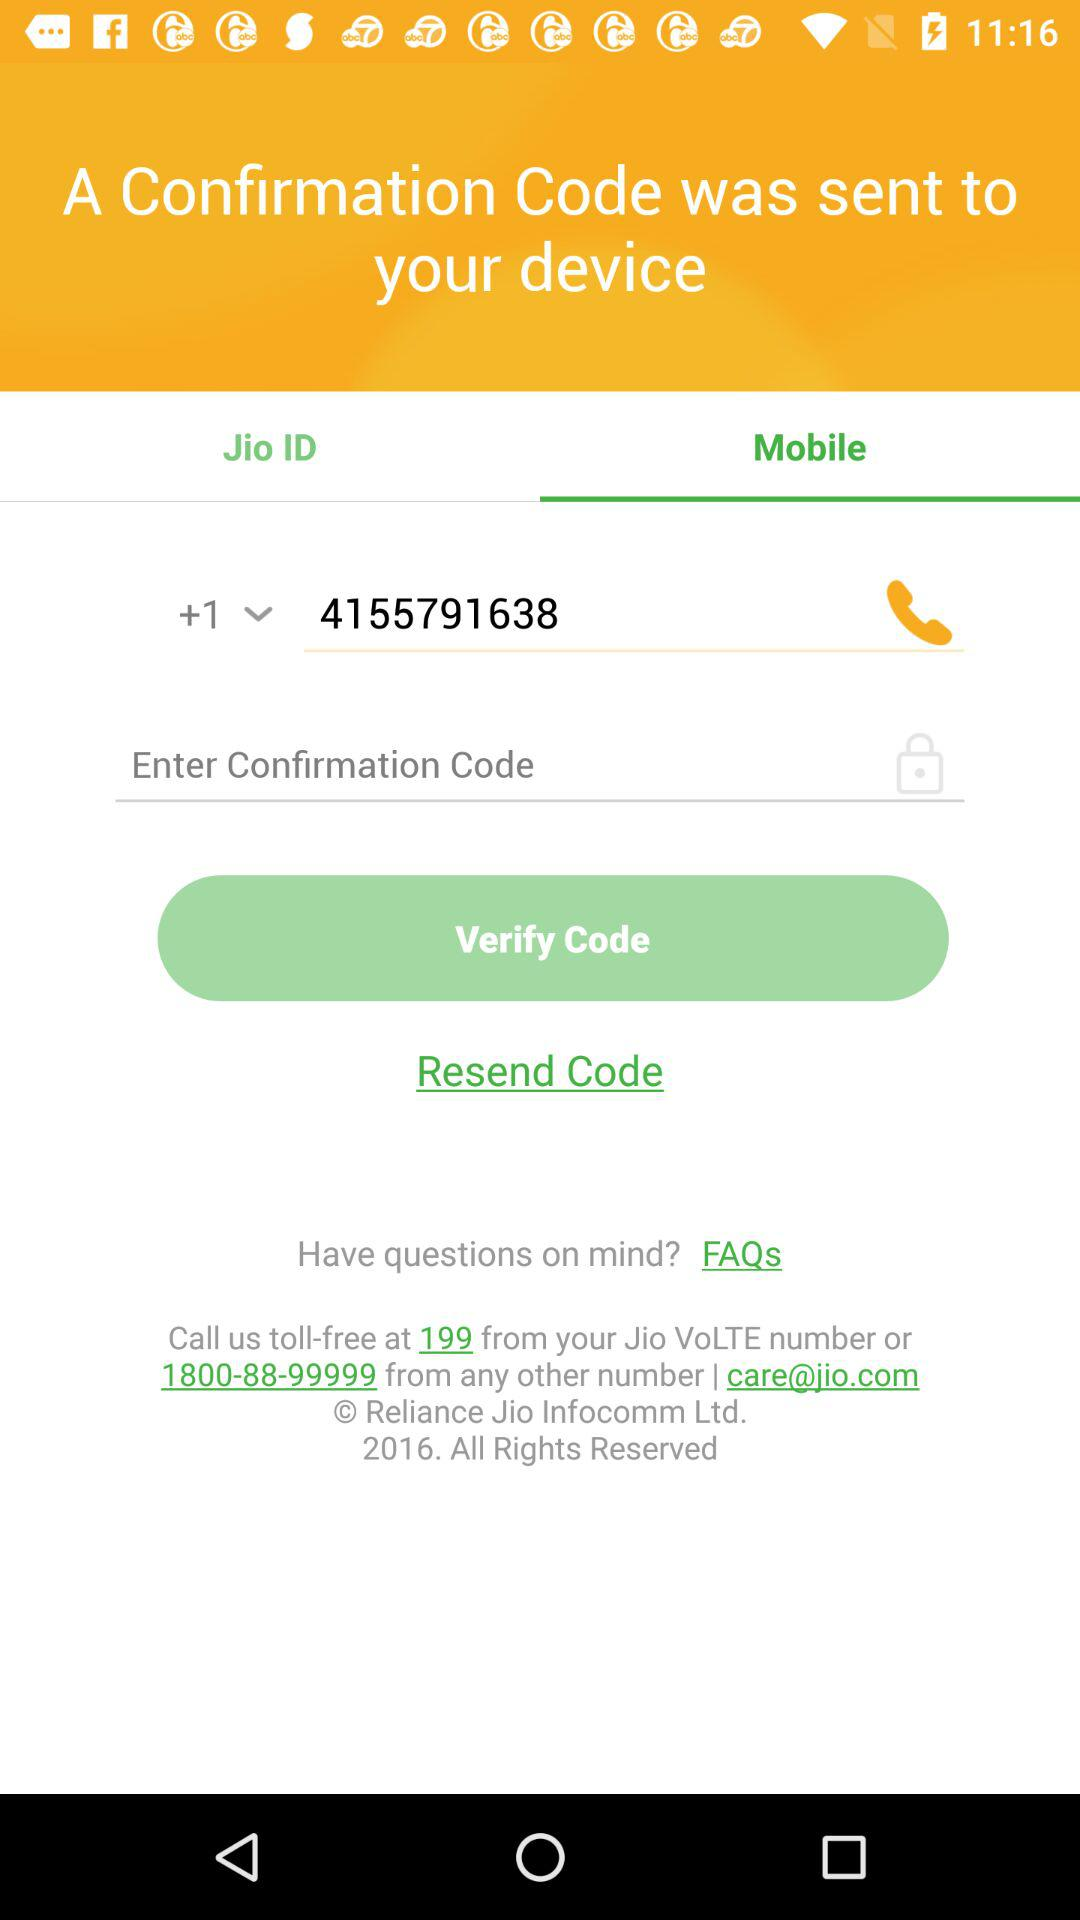Which tab is selected? The selected tab is "Mobile". 